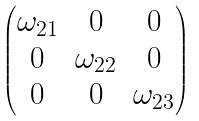Convert formula to latex. <formula><loc_0><loc_0><loc_500><loc_500>\begin{pmatrix} \omega _ { 2 1 } & 0 & 0 \\ 0 & \omega _ { 2 2 } & 0 \\ 0 & 0 & \omega _ { 2 3 } \end{pmatrix}</formula> 